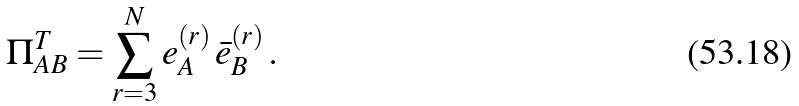Convert formula to latex. <formula><loc_0><loc_0><loc_500><loc_500>\Pi ^ { T } _ { A B } = \sum _ { r = 3 } ^ { N } e ^ { ( r ) } _ { A } \, \bar { e } ^ { ( r ) } _ { B } \, .</formula> 